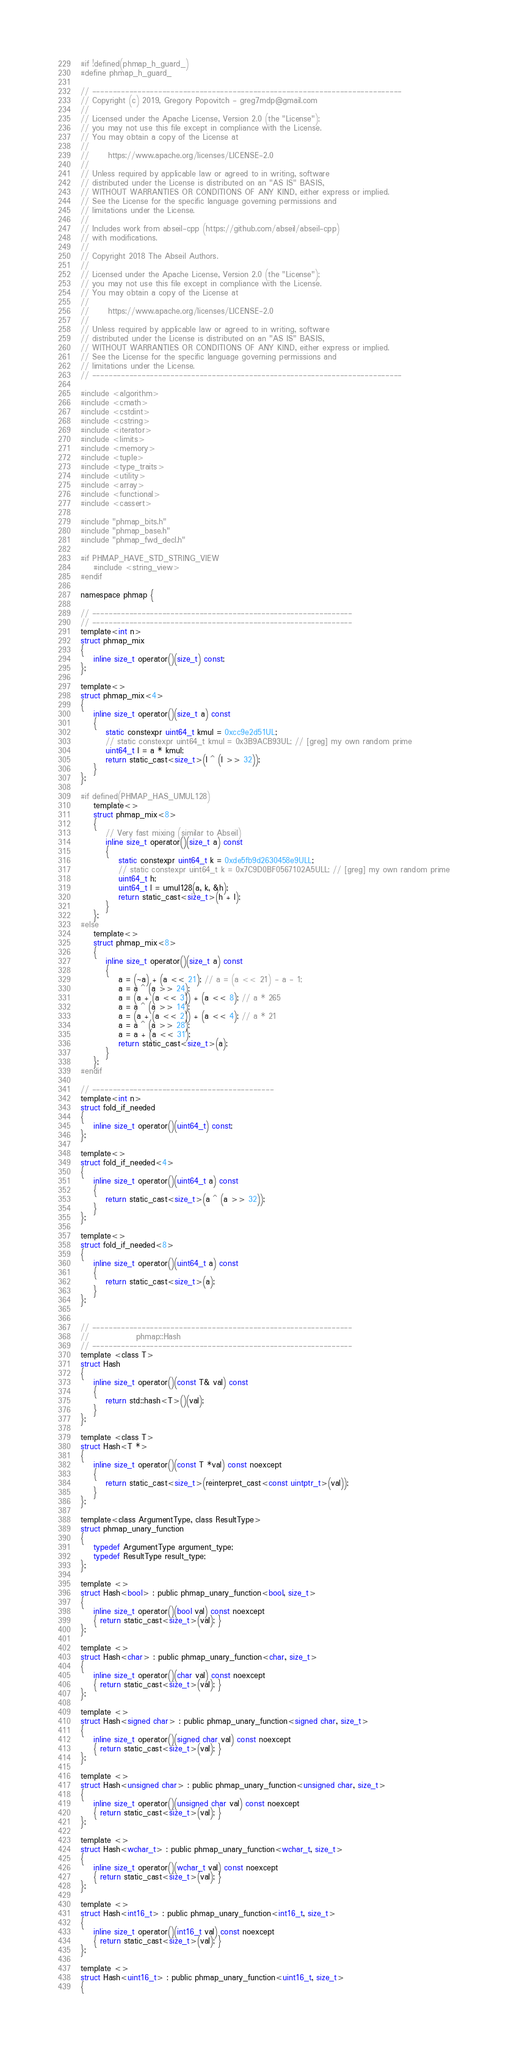<code> <loc_0><loc_0><loc_500><loc_500><_C_>#if !defined(phmap_h_guard_)
#define phmap_h_guard_

// ---------------------------------------------------------------------------
// Copyright (c) 2019, Gregory Popovitch - greg7mdp@gmail.com
//
// Licensed under the Apache License, Version 2.0 (the "License");
// you may not use this file except in compliance with the License.
// You may obtain a copy of the License at
//
//      https://www.apache.org/licenses/LICENSE-2.0
//
// Unless required by applicable law or agreed to in writing, software
// distributed under the License is distributed on an "AS IS" BASIS,
// WITHOUT WARRANTIES OR CONDITIONS OF ANY KIND, either express or implied.
// See the License for the specific language governing permissions and
// limitations under the License.
//
// Includes work from abseil-cpp (https://github.com/abseil/abseil-cpp)
// with modifications.
// 
// Copyright 2018 The Abseil Authors.
//
// Licensed under the Apache License, Version 2.0 (the "License");
// you may not use this file except in compliance with the License.
// You may obtain a copy of the License at
//
//      https://www.apache.org/licenses/LICENSE-2.0
//
// Unless required by applicable law or agreed to in writing, software
// distributed under the License is distributed on an "AS IS" BASIS,
// WITHOUT WARRANTIES OR CONDITIONS OF ANY KIND, either express or implied.
// See the License for the specific language governing permissions and
// limitations under the License.
// ---------------------------------------------------------------------------

#include <algorithm>
#include <cmath>
#include <cstdint>
#include <cstring>
#include <iterator>
#include <limits>
#include <memory>
#include <tuple>
#include <type_traits>
#include <utility>
#include <array>
#include <functional>
#include <cassert>

#include "phmap_bits.h"
#include "phmap_base.h"
#include "phmap_fwd_decl.h"

#if PHMAP_HAVE_STD_STRING_VIEW
    #include <string_view>
#endif

namespace phmap {

// ---------------------------------------------------------------
// ---------------------------------------------------------------
template<int n> 
struct phmap_mix
{
    inline size_t operator()(size_t) const;
};

template<>
struct phmap_mix<4>
{
    inline size_t operator()(size_t a) const
    {
        static constexpr uint64_t kmul = 0xcc9e2d51UL;
        // static constexpr uint64_t kmul = 0x3B9ACB93UL; // [greg] my own random prime
        uint64_t l = a * kmul;
        return static_cast<size_t>(l ^ (l >> 32));
    }
};

#if defined(PHMAP_HAS_UMUL128)
    template<>
    struct phmap_mix<8>
    {
        // Very fast mixing (similar to Abseil)
        inline size_t operator()(size_t a) const
        {
            static constexpr uint64_t k = 0xde5fb9d2630458e9ULL;
            // static constexpr uint64_t k = 0x7C9D0BF0567102A5ULL; // [greg] my own random prime
            uint64_t h;
            uint64_t l = umul128(a, k, &h);
            return static_cast<size_t>(h + l);
        }
    };
#else
    template<>
    struct phmap_mix<8>
    {
        inline size_t operator()(size_t a) const
        {
            a = (~a) + (a << 21); // a = (a << 21) - a - 1;
            a = a ^ (a >> 24);
            a = (a + (a << 3)) + (a << 8); // a * 265
            a = a ^ (a >> 14);
            a = (a + (a << 2)) + (a << 4); // a * 21
            a = a ^ (a >> 28);
            a = a + (a << 31);
            return static_cast<size_t>(a);
        }
    };
#endif

// --------------------------------------------
template<int n> 
struct fold_if_needed
{
    inline size_t operator()(uint64_t) const;
};

template<>
struct fold_if_needed<4>
{
    inline size_t operator()(uint64_t a) const
    {
        return static_cast<size_t>(a ^ (a >> 32));
    }
};

template<>
struct fold_if_needed<8>
{
    inline size_t operator()(uint64_t a) const
    {
        return static_cast<size_t>(a);
    }
};


// ---------------------------------------------------------------
//               phmap::Hash
// ---------------------------------------------------------------
template <class T>
struct Hash
{
    inline size_t operator()(const T& val) const
    {
        return std::hash<T>()(val);
    }
};

template <class T>
struct Hash<T *>
{
    inline size_t operator()(const T *val) const noexcept
    {
        return static_cast<size_t>(reinterpret_cast<const uintptr_t>(val)); 
    }
};

template<class ArgumentType, class ResultType>
struct phmap_unary_function
{
    typedef ArgumentType argument_type;
    typedef ResultType result_type;
};

template <>
struct Hash<bool> : public phmap_unary_function<bool, size_t>
{
    inline size_t operator()(bool val) const noexcept
    { return static_cast<size_t>(val); }
};

template <>
struct Hash<char> : public phmap_unary_function<char, size_t>
{
    inline size_t operator()(char val) const noexcept
    { return static_cast<size_t>(val); }
};

template <>
struct Hash<signed char> : public phmap_unary_function<signed char, size_t>
{
    inline size_t operator()(signed char val) const noexcept
    { return static_cast<size_t>(val); }
};

template <>
struct Hash<unsigned char> : public phmap_unary_function<unsigned char, size_t>
{
    inline size_t operator()(unsigned char val) const noexcept
    { return static_cast<size_t>(val); }
};

template <>
struct Hash<wchar_t> : public phmap_unary_function<wchar_t, size_t>
{
    inline size_t operator()(wchar_t val) const noexcept
    { return static_cast<size_t>(val); }
};

template <>
struct Hash<int16_t> : public phmap_unary_function<int16_t, size_t>
{
    inline size_t operator()(int16_t val) const noexcept
    { return static_cast<size_t>(val); }
};

template <>
struct Hash<uint16_t> : public phmap_unary_function<uint16_t, size_t>
{</code> 